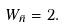Convert formula to latex. <formula><loc_0><loc_0><loc_500><loc_500>W _ { \bar { n } } = 2 .</formula> 